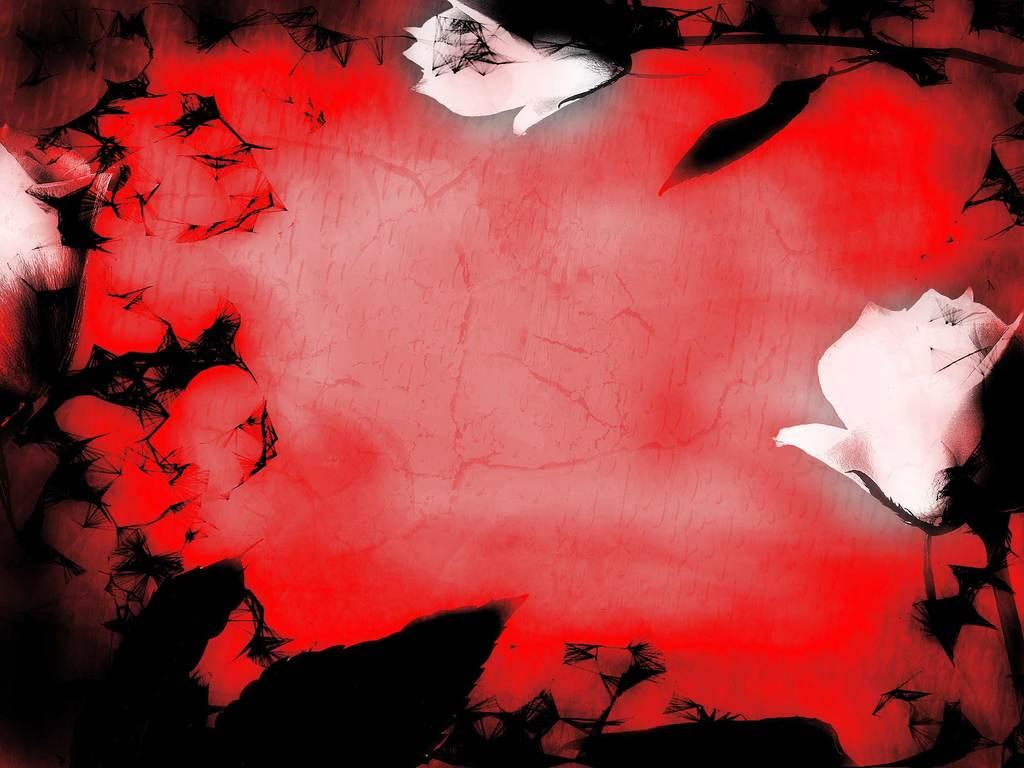What type of plants can be seen in the image? There are flowers in the image. What color is the background of the image? The background of the image is red. How does the distribution of the flowers affect the playground in the image? There is no playground present in the image, so the distribution of the flowers does not affect it. 